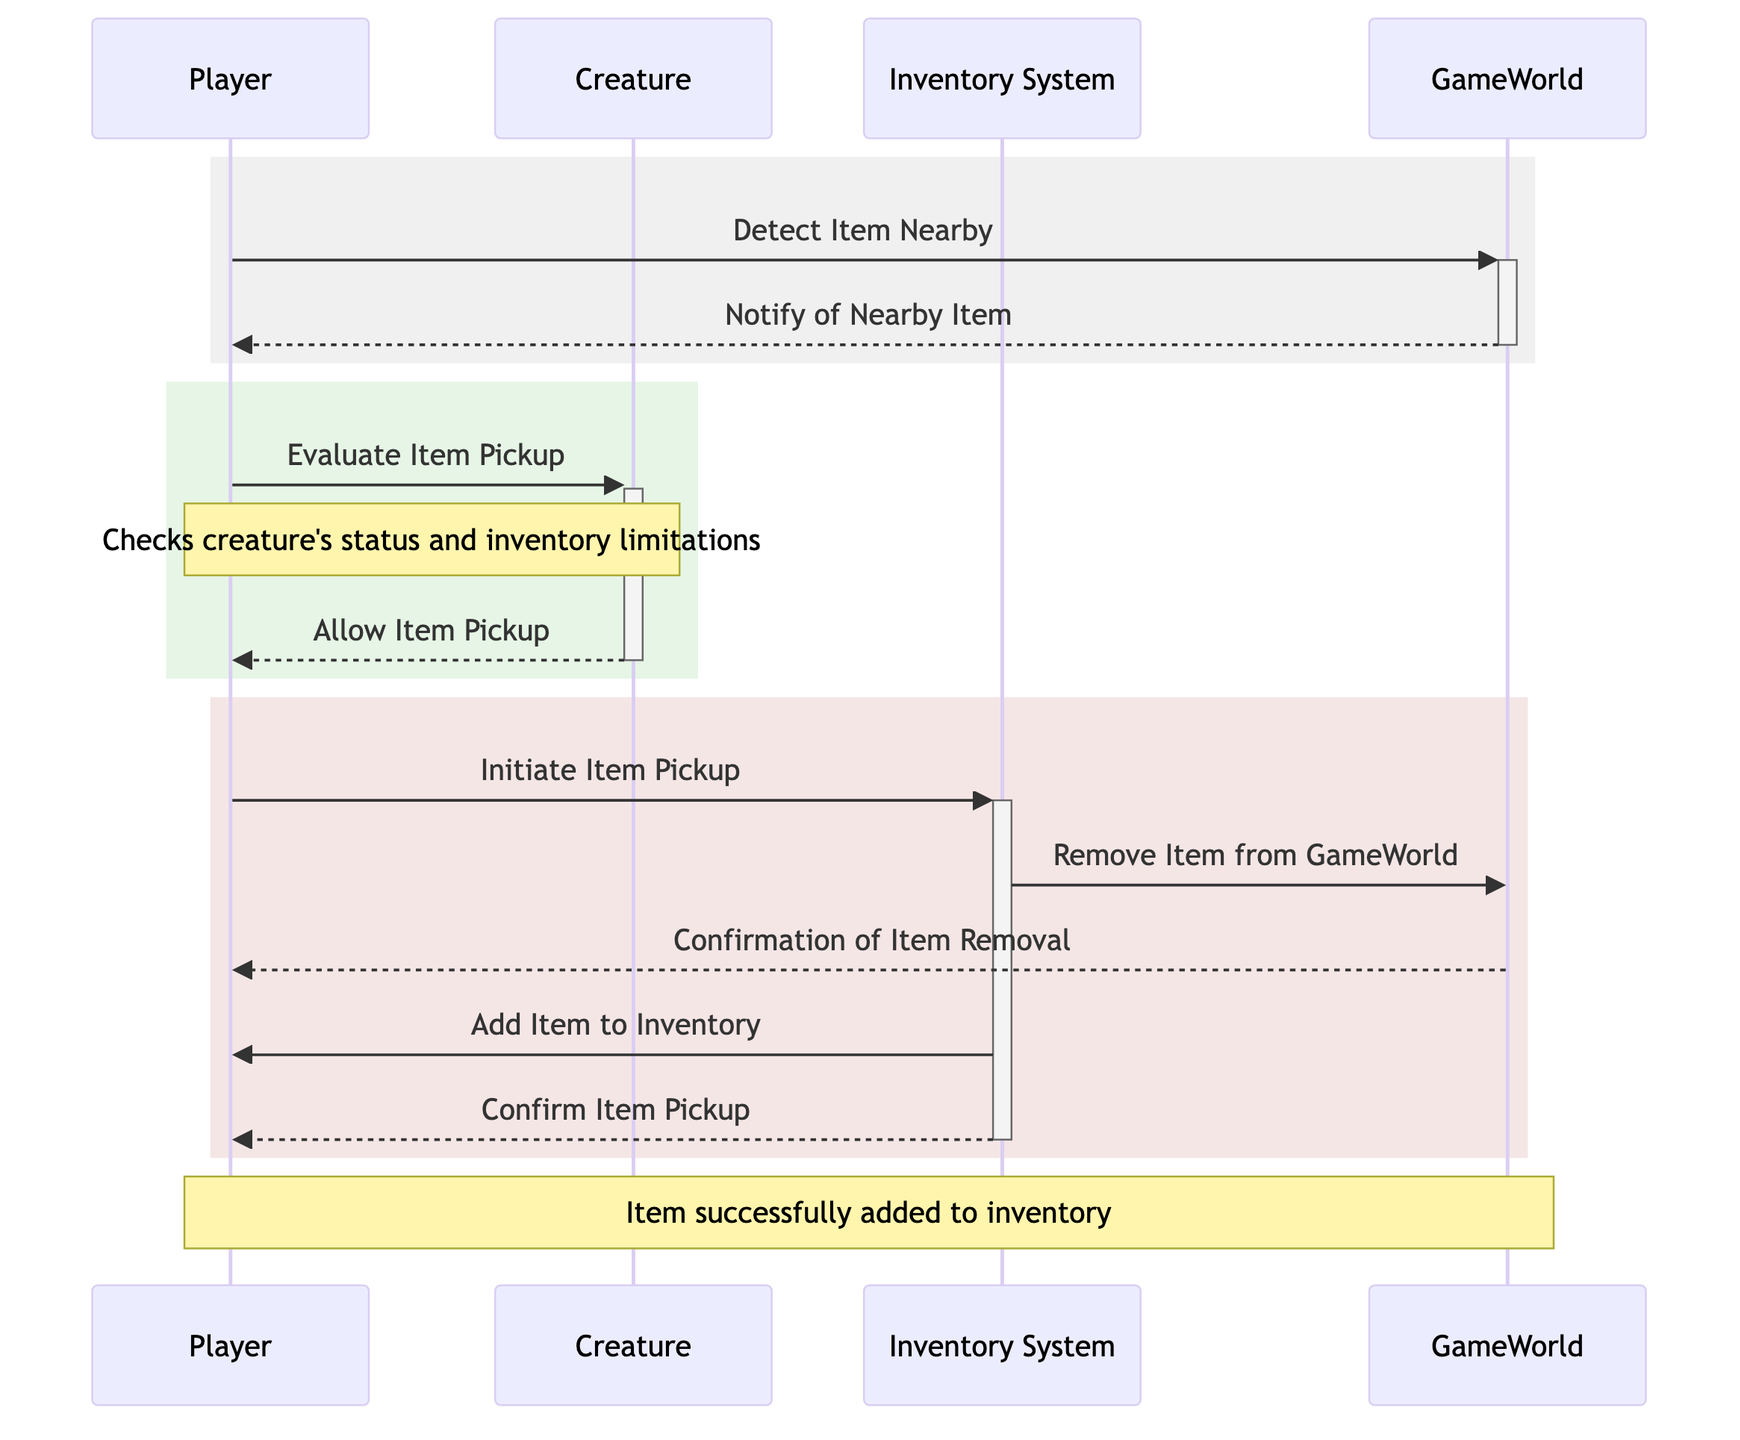What actors are involved in the diagram? The actors listed in the diagram are Player, Creature, Inventory System, and GameWorld. Each of these actors plays a role in the inventory management and item pickup process, as seen in the interactions depicted.
Answer: Player, Creature, Inventory System, GameWorld How many messages are exchanged between the Player and GameWorld? The diagram shows three messages exchanged between the Player and GameWorld: "Detect Item Nearby," "Notify of Nearby Item," and "Confirmation of Item Removal." These illustrate the interactions regarding item detection and confirmation of item management in the game world.
Answer: 3 Which actor initiates the Item Pickup process? The process of picking up an item is initiated by the Player, who sends a message to the Inventory System to start the item pickup after evaluating the creature's status and inventory limitations.
Answer: Player What is the message sent from the Creature to the Player? The message sent from the Creature to the Player is "Allow Item Pickup." This indicates that the creature has evaluated the player's ability to pick up the item and has granted permission.
Answer: Allow Item Pickup What does the Inventory System do after removing the item from GameWorld? After removing the item from GameWorld, the Inventory System adds the item to the player's inventory, which is indicated by the message "Add Item to Inventory." This step is crucial for updating the player's inventory status following a successful pickup.
Answer: Add Item to Inventory Explain the sequence of events that lead to the confirmation of Item Pickup. First, the Player detects an item nearby and receives a notification from GameWorld. Next, the Player evaluates the item pickup with the Creature, who allows the pickup. Then, the Player initiates the pickup with the Inventory System, which removes the item from GameWorld. Finally, the Inventory System confirms the item has been added to the Player's inventory, completing the process.
Answer: Player detects item, evaluates with Creature, initiates with Inventory System, confirmation received What is the outcome following the last message in the diagram? After the last message "Confirm Item Pickup," the outcome is that the item has been successfully added to the Player's inventory. This is confirmed by the note mentioned at the end of the diagram, indicating the successful transaction.
Answer: Item successfully added to inventory 